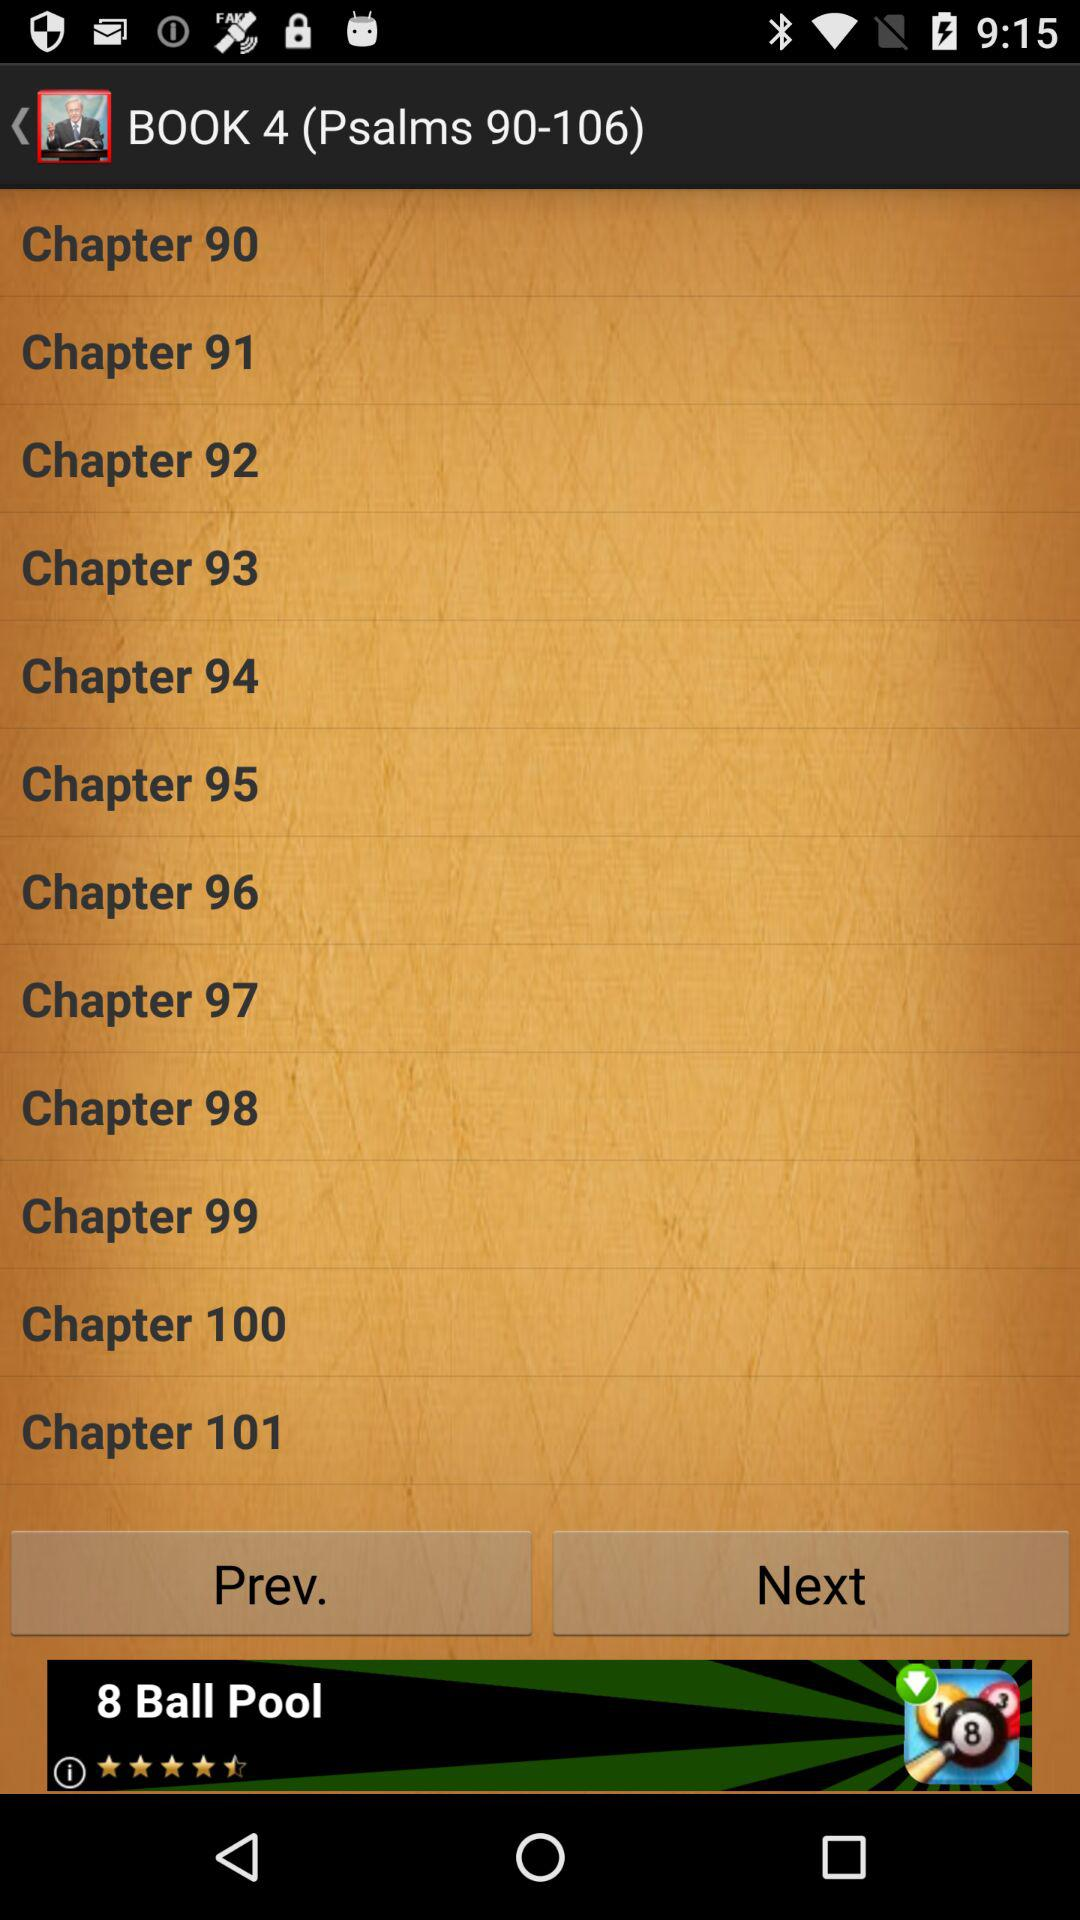How many verses are in chapter 2?
Answer the question using a single word or phrase. 9 